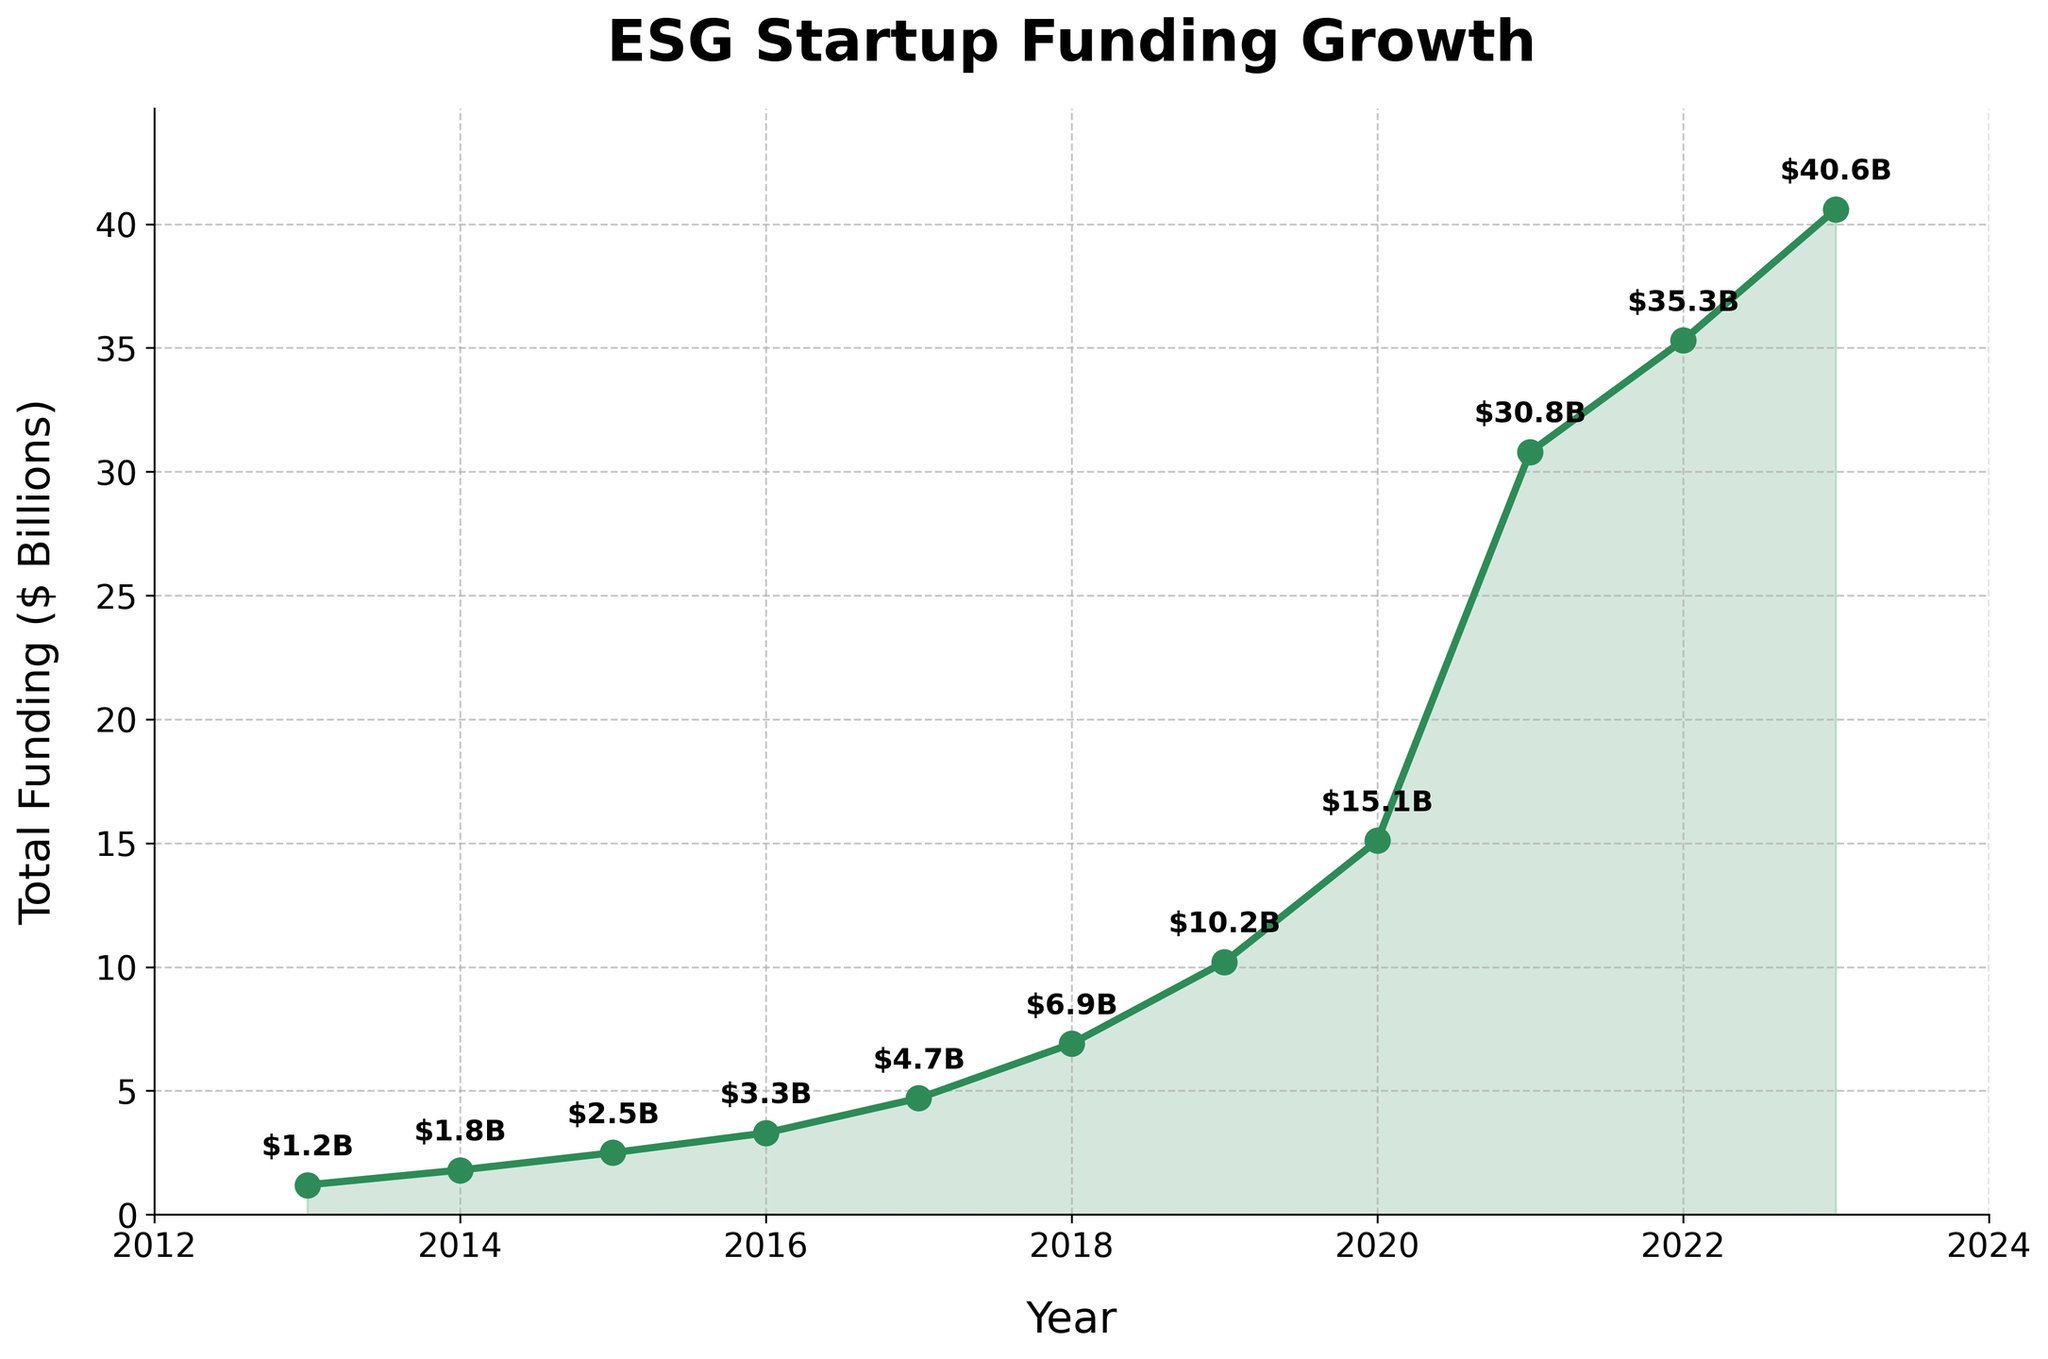What is the overall trend of ESG startup funding from 2013 to 2023? The overall trend is observed by looking at the increasing line marking the total funding over the years. It shows a consistent increase, indicating a growing interest in ESG startups.
Answer: Increasing trend Which year experienced the highest annual funding increase compared to the previous year? To find this, calculate the differences in funding between consecutive years and identify the maximum difference. The largest increase is between 2020 and 2021, with $30.8B - $15.1B = $15.7B.
Answer: 2021 How much did the total funding increase from 2013 to 2023 in billions? Subtract the funding amount in 2013 from the funding amount in 2023: $40.6B - $1.2B = $39.4B.
Answer: $39.4B In which years did the funding double compared to the previous year? Identify years where the funding amount was at least twice that of the previous year. Funding doubled between 2019 ($10.2B) and 2020 ($15.1B) and again between 2020 and 2021 ($30.8B).
Answer: 2018, 2020 Which year had the smallest increase in funding compared to the previous year? Calculate the differences in funding between consecutive years and find the minimum difference. The smallest increase is between 2014 and 2015, with $2.5B - $1.8B = $0.7B.
Answer: 2014 Between which two consecutive years did ESG funding see more than a $10B increase? Identify the years where the difference in funding surpasses $10B. The increase from 2020 ($15.1B) to 2021 ($30.8B) and from 2021 ($30.8B) to 2022 ($35.3B) fits this criterion.
Answer: 2021 and 2022 What is the average annual increase in ESG startup funding over the decade? Calculate the total increase from 2013 to 2023, which is $39.4B, and divide by the number of years: $39.4B / 10 = $3.94B per year.
Answer: $3.94B By how much did the funding increase from 2015 to 2020? Subtract the funding amount in 2015 from the funding amount in 2020: $15.1B - $2.5B = $12.6B.
Answer: $12.6B Which year showed a funding amount that was halfway between the 2013 and 2023 funding levels? A halfway point in funding is $1.2B + ($40.6B - $1.2B) / 2 = $20.9B. By examining the chart, 2021 had $30.8B, which is closest to halfway when considering compounded growth.
Answer: 2020 